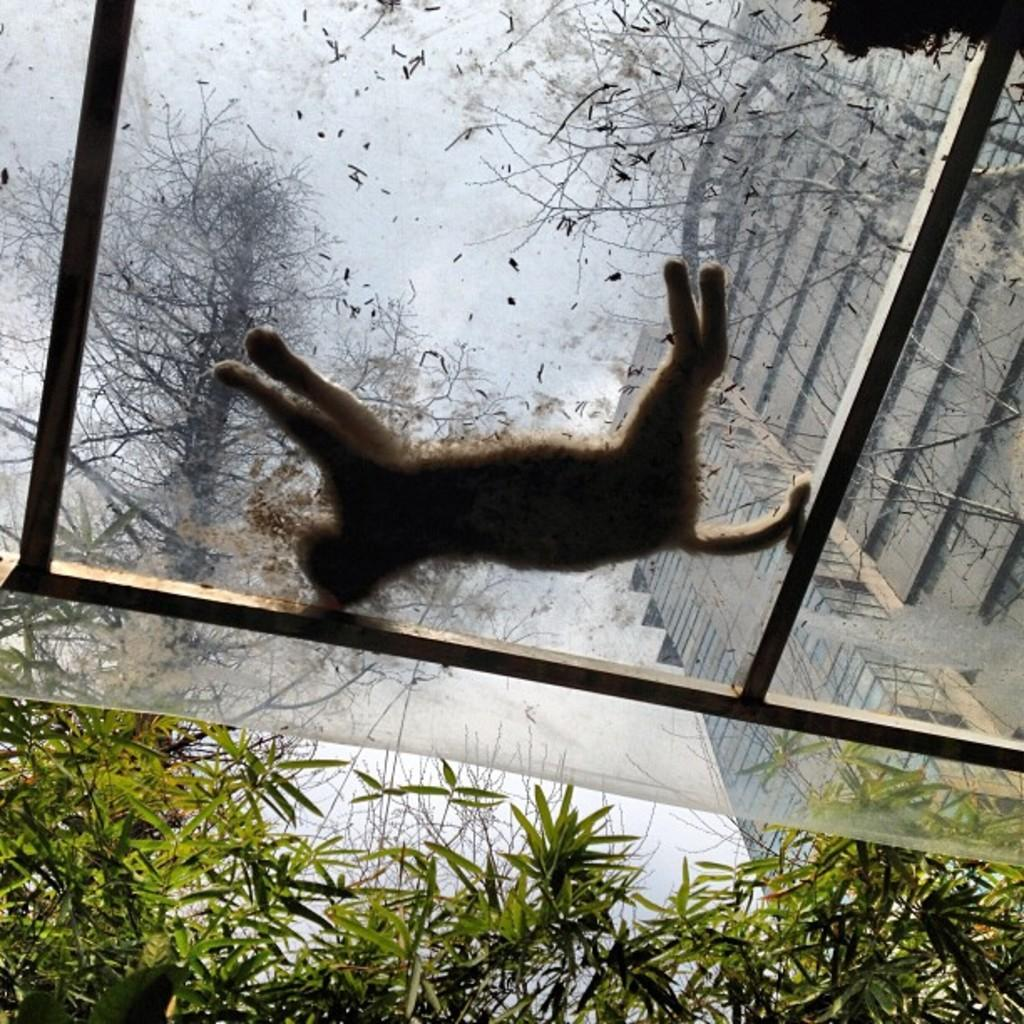What can be seen in the foreground of the image? There are trees in the foreground of the image. What object is present in the image besides the trees? There is a plastic cover in the image. What is lying on the plastic cover? A cat is lying on the plastic cover. What type of approval is the cat seeking in the image? The image does not depict the cat seeking any approval; it is simply lying on the plastic cover. Is there a carriage visible in the image? No, there is no carriage present in the image. 